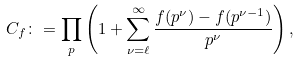Convert formula to latex. <formula><loc_0><loc_0><loc_500><loc_500>C _ { f } \colon = \prod _ { p } \left ( 1 + \sum _ { \nu = \ell } ^ { \infty } \frac { f ( p ^ { \nu } ) - f ( p ^ { \nu - 1 } ) } { p ^ { \nu } } \right ) ,</formula> 